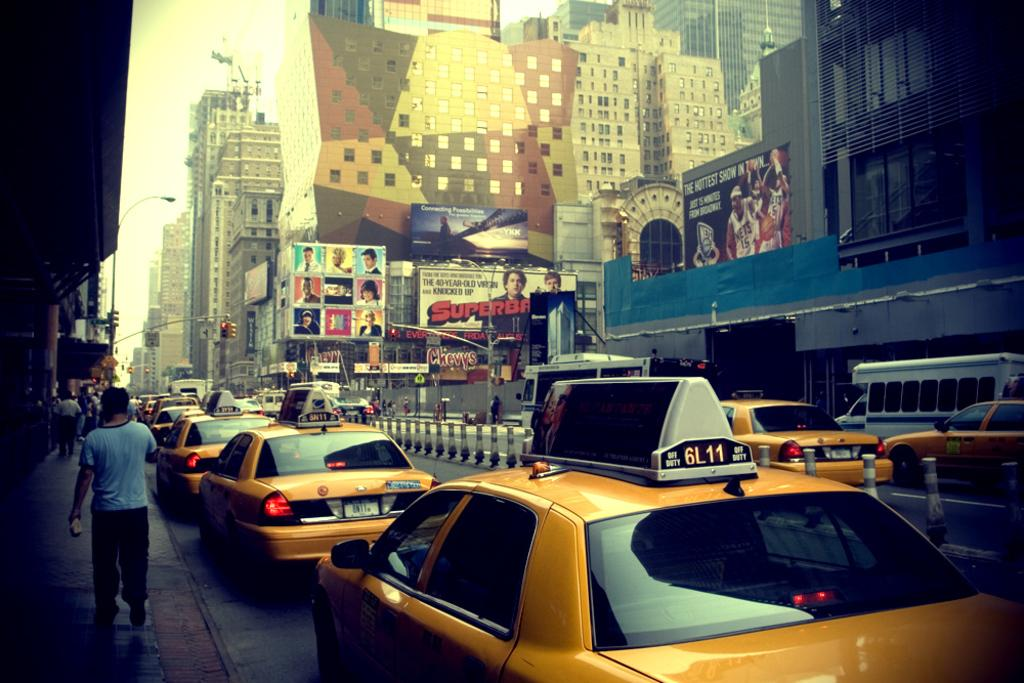<image>
Share a concise interpretation of the image provided. Many taxis are on the city street and Superbad is currently playing in theaters. 